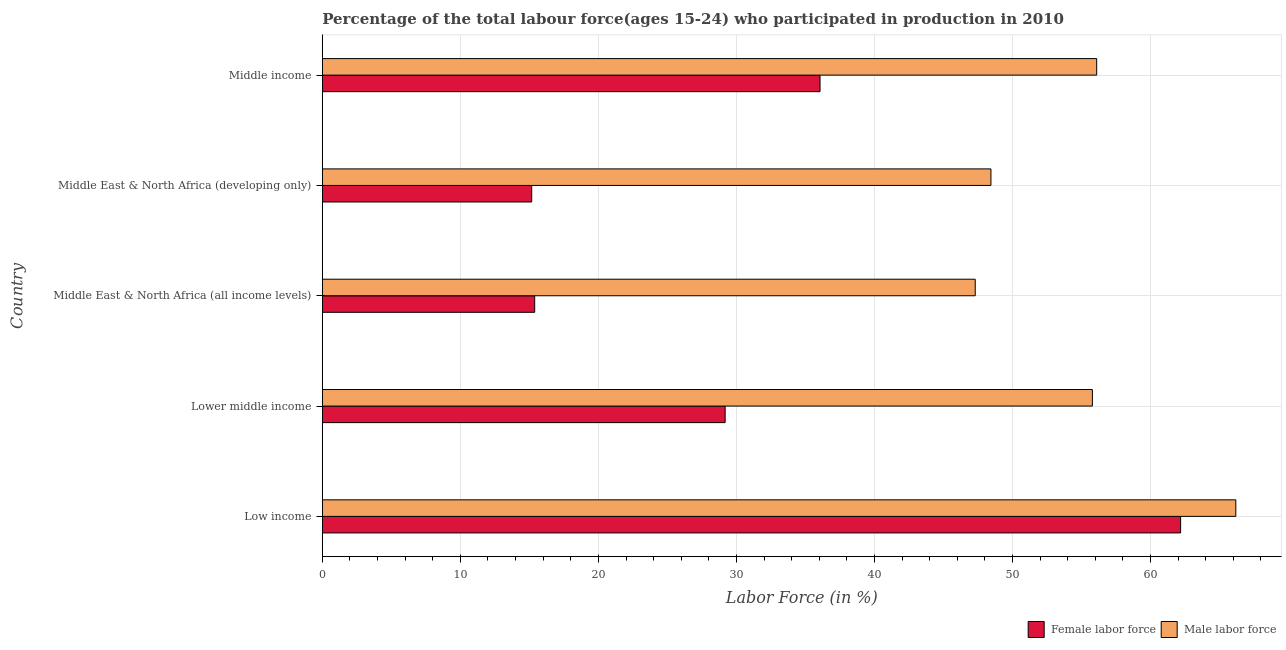How many groups of bars are there?
Offer a very short reply. 5. Are the number of bars per tick equal to the number of legend labels?
Keep it short and to the point. Yes. What is the label of the 1st group of bars from the top?
Your response must be concise. Middle income. In how many cases, is the number of bars for a given country not equal to the number of legend labels?
Keep it short and to the point. 0. What is the percentage of male labour force in Middle East & North Africa (developing only)?
Keep it short and to the point. 48.44. Across all countries, what is the maximum percentage of female labor force?
Your answer should be very brief. 62.18. Across all countries, what is the minimum percentage of male labour force?
Give a very brief answer. 47.3. In which country was the percentage of male labour force minimum?
Offer a very short reply. Middle East & North Africa (all income levels). What is the total percentage of female labor force in the graph?
Provide a short and direct response. 157.97. What is the difference between the percentage of female labor force in Low income and that in Middle East & North Africa (all income levels)?
Make the answer very short. 46.79. What is the difference between the percentage of male labour force in Middle income and the percentage of female labor force in Middle East & North Africa (developing only)?
Provide a short and direct response. 40.93. What is the average percentage of male labour force per country?
Your answer should be compact. 54.76. What is the difference between the percentage of female labor force and percentage of male labour force in Lower middle income?
Offer a very short reply. -26.61. In how many countries, is the percentage of female labor force greater than 64 %?
Give a very brief answer. 0. What is the ratio of the percentage of female labor force in Lower middle income to that in Middle East & North Africa (developing only)?
Offer a terse response. 1.92. Is the percentage of male labour force in Low income less than that in Lower middle income?
Provide a succinct answer. No. Is the difference between the percentage of male labour force in Middle East & North Africa (developing only) and Middle income greater than the difference between the percentage of female labor force in Middle East & North Africa (developing only) and Middle income?
Keep it short and to the point. Yes. What is the difference between the highest and the second highest percentage of female labor force?
Ensure brevity in your answer.  26.12. What is the difference between the highest and the lowest percentage of male labour force?
Your answer should be compact. 18.88. What does the 2nd bar from the top in Middle income represents?
Offer a very short reply. Female labor force. What does the 2nd bar from the bottom in Middle East & North Africa (all income levels) represents?
Offer a very short reply. Male labor force. What is the difference between two consecutive major ticks on the X-axis?
Provide a succinct answer. 10. Does the graph contain any zero values?
Your answer should be very brief. No. Where does the legend appear in the graph?
Offer a very short reply. Bottom right. What is the title of the graph?
Your answer should be very brief. Percentage of the total labour force(ages 15-24) who participated in production in 2010. Does "Urban Population" appear as one of the legend labels in the graph?
Your response must be concise. No. What is the label or title of the X-axis?
Make the answer very short. Labor Force (in %). What is the Labor Force (in %) of Female labor force in Low income?
Give a very brief answer. 62.18. What is the Labor Force (in %) in Male labor force in Low income?
Offer a terse response. 66.18. What is the Labor Force (in %) of Female labor force in Lower middle income?
Your answer should be compact. 29.18. What is the Labor Force (in %) of Male labor force in Lower middle income?
Provide a short and direct response. 55.79. What is the Labor Force (in %) in Female labor force in Middle East & North Africa (all income levels)?
Your response must be concise. 15.38. What is the Labor Force (in %) of Male labor force in Middle East & North Africa (all income levels)?
Your response must be concise. 47.3. What is the Labor Force (in %) in Female labor force in Middle East & North Africa (developing only)?
Keep it short and to the point. 15.17. What is the Labor Force (in %) in Male labor force in Middle East & North Africa (developing only)?
Offer a very short reply. 48.44. What is the Labor Force (in %) of Female labor force in Middle income?
Offer a terse response. 36.06. What is the Labor Force (in %) of Male labor force in Middle income?
Offer a terse response. 56.1. Across all countries, what is the maximum Labor Force (in %) in Female labor force?
Provide a short and direct response. 62.18. Across all countries, what is the maximum Labor Force (in %) of Male labor force?
Your answer should be very brief. 66.18. Across all countries, what is the minimum Labor Force (in %) in Female labor force?
Ensure brevity in your answer.  15.17. Across all countries, what is the minimum Labor Force (in %) in Male labor force?
Your answer should be compact. 47.3. What is the total Labor Force (in %) of Female labor force in the graph?
Offer a very short reply. 157.97. What is the total Labor Force (in %) in Male labor force in the graph?
Your answer should be very brief. 273.8. What is the difference between the Labor Force (in %) in Female labor force in Low income and that in Lower middle income?
Provide a short and direct response. 33. What is the difference between the Labor Force (in %) of Male labor force in Low income and that in Lower middle income?
Offer a very short reply. 10.39. What is the difference between the Labor Force (in %) in Female labor force in Low income and that in Middle East & North Africa (all income levels)?
Offer a terse response. 46.79. What is the difference between the Labor Force (in %) in Male labor force in Low income and that in Middle East & North Africa (all income levels)?
Your answer should be compact. 18.88. What is the difference between the Labor Force (in %) of Female labor force in Low income and that in Middle East & North Africa (developing only)?
Your response must be concise. 47.01. What is the difference between the Labor Force (in %) in Male labor force in Low income and that in Middle East & North Africa (developing only)?
Offer a terse response. 17.74. What is the difference between the Labor Force (in %) of Female labor force in Low income and that in Middle income?
Offer a very short reply. 26.12. What is the difference between the Labor Force (in %) of Male labor force in Low income and that in Middle income?
Offer a terse response. 10.08. What is the difference between the Labor Force (in %) of Female labor force in Lower middle income and that in Middle East & North Africa (all income levels)?
Give a very brief answer. 13.8. What is the difference between the Labor Force (in %) of Male labor force in Lower middle income and that in Middle East & North Africa (all income levels)?
Ensure brevity in your answer.  8.49. What is the difference between the Labor Force (in %) in Female labor force in Lower middle income and that in Middle East & North Africa (developing only)?
Ensure brevity in your answer.  14.01. What is the difference between the Labor Force (in %) in Male labor force in Lower middle income and that in Middle East & North Africa (developing only)?
Keep it short and to the point. 7.35. What is the difference between the Labor Force (in %) in Female labor force in Lower middle income and that in Middle income?
Provide a succinct answer. -6.87. What is the difference between the Labor Force (in %) of Male labor force in Lower middle income and that in Middle income?
Offer a very short reply. -0.31. What is the difference between the Labor Force (in %) in Female labor force in Middle East & North Africa (all income levels) and that in Middle East & North Africa (developing only)?
Keep it short and to the point. 0.22. What is the difference between the Labor Force (in %) in Male labor force in Middle East & North Africa (all income levels) and that in Middle East & North Africa (developing only)?
Provide a short and direct response. -1.14. What is the difference between the Labor Force (in %) in Female labor force in Middle East & North Africa (all income levels) and that in Middle income?
Make the answer very short. -20.67. What is the difference between the Labor Force (in %) in Male labor force in Middle East & North Africa (all income levels) and that in Middle income?
Keep it short and to the point. -8.8. What is the difference between the Labor Force (in %) in Female labor force in Middle East & North Africa (developing only) and that in Middle income?
Your response must be concise. -20.89. What is the difference between the Labor Force (in %) of Male labor force in Middle East & North Africa (developing only) and that in Middle income?
Your answer should be very brief. -7.66. What is the difference between the Labor Force (in %) in Female labor force in Low income and the Labor Force (in %) in Male labor force in Lower middle income?
Provide a short and direct response. 6.39. What is the difference between the Labor Force (in %) in Female labor force in Low income and the Labor Force (in %) in Male labor force in Middle East & North Africa (all income levels)?
Provide a succinct answer. 14.88. What is the difference between the Labor Force (in %) in Female labor force in Low income and the Labor Force (in %) in Male labor force in Middle East & North Africa (developing only)?
Provide a short and direct response. 13.74. What is the difference between the Labor Force (in %) of Female labor force in Low income and the Labor Force (in %) of Male labor force in Middle income?
Offer a terse response. 6.08. What is the difference between the Labor Force (in %) in Female labor force in Lower middle income and the Labor Force (in %) in Male labor force in Middle East & North Africa (all income levels)?
Give a very brief answer. -18.12. What is the difference between the Labor Force (in %) in Female labor force in Lower middle income and the Labor Force (in %) in Male labor force in Middle East & North Africa (developing only)?
Give a very brief answer. -19.26. What is the difference between the Labor Force (in %) of Female labor force in Lower middle income and the Labor Force (in %) of Male labor force in Middle income?
Provide a succinct answer. -26.92. What is the difference between the Labor Force (in %) in Female labor force in Middle East & North Africa (all income levels) and the Labor Force (in %) in Male labor force in Middle East & North Africa (developing only)?
Your response must be concise. -33.05. What is the difference between the Labor Force (in %) in Female labor force in Middle East & North Africa (all income levels) and the Labor Force (in %) in Male labor force in Middle income?
Offer a very short reply. -40.71. What is the difference between the Labor Force (in %) of Female labor force in Middle East & North Africa (developing only) and the Labor Force (in %) of Male labor force in Middle income?
Give a very brief answer. -40.93. What is the average Labor Force (in %) of Female labor force per country?
Provide a short and direct response. 31.59. What is the average Labor Force (in %) in Male labor force per country?
Make the answer very short. 54.76. What is the difference between the Labor Force (in %) in Female labor force and Labor Force (in %) in Male labor force in Low income?
Your answer should be very brief. -4. What is the difference between the Labor Force (in %) of Female labor force and Labor Force (in %) of Male labor force in Lower middle income?
Give a very brief answer. -26.61. What is the difference between the Labor Force (in %) in Female labor force and Labor Force (in %) in Male labor force in Middle East & North Africa (all income levels)?
Offer a terse response. -31.91. What is the difference between the Labor Force (in %) of Female labor force and Labor Force (in %) of Male labor force in Middle East & North Africa (developing only)?
Your response must be concise. -33.27. What is the difference between the Labor Force (in %) of Female labor force and Labor Force (in %) of Male labor force in Middle income?
Keep it short and to the point. -20.04. What is the ratio of the Labor Force (in %) in Female labor force in Low income to that in Lower middle income?
Your response must be concise. 2.13. What is the ratio of the Labor Force (in %) in Male labor force in Low income to that in Lower middle income?
Your answer should be compact. 1.19. What is the ratio of the Labor Force (in %) in Female labor force in Low income to that in Middle East & North Africa (all income levels)?
Make the answer very short. 4.04. What is the ratio of the Labor Force (in %) in Male labor force in Low income to that in Middle East & North Africa (all income levels)?
Keep it short and to the point. 1.4. What is the ratio of the Labor Force (in %) of Female labor force in Low income to that in Middle East & North Africa (developing only)?
Your response must be concise. 4.1. What is the ratio of the Labor Force (in %) in Male labor force in Low income to that in Middle East & North Africa (developing only)?
Keep it short and to the point. 1.37. What is the ratio of the Labor Force (in %) in Female labor force in Low income to that in Middle income?
Your answer should be compact. 1.72. What is the ratio of the Labor Force (in %) in Male labor force in Low income to that in Middle income?
Your answer should be very brief. 1.18. What is the ratio of the Labor Force (in %) of Female labor force in Lower middle income to that in Middle East & North Africa (all income levels)?
Ensure brevity in your answer.  1.9. What is the ratio of the Labor Force (in %) in Male labor force in Lower middle income to that in Middle East & North Africa (all income levels)?
Provide a succinct answer. 1.18. What is the ratio of the Labor Force (in %) in Female labor force in Lower middle income to that in Middle East & North Africa (developing only)?
Keep it short and to the point. 1.92. What is the ratio of the Labor Force (in %) in Male labor force in Lower middle income to that in Middle East & North Africa (developing only)?
Ensure brevity in your answer.  1.15. What is the ratio of the Labor Force (in %) in Female labor force in Lower middle income to that in Middle income?
Ensure brevity in your answer.  0.81. What is the ratio of the Labor Force (in %) in Male labor force in Lower middle income to that in Middle income?
Make the answer very short. 0.99. What is the ratio of the Labor Force (in %) in Female labor force in Middle East & North Africa (all income levels) to that in Middle East & North Africa (developing only)?
Offer a very short reply. 1.01. What is the ratio of the Labor Force (in %) of Male labor force in Middle East & North Africa (all income levels) to that in Middle East & North Africa (developing only)?
Your response must be concise. 0.98. What is the ratio of the Labor Force (in %) of Female labor force in Middle East & North Africa (all income levels) to that in Middle income?
Make the answer very short. 0.43. What is the ratio of the Labor Force (in %) of Male labor force in Middle East & North Africa (all income levels) to that in Middle income?
Your answer should be very brief. 0.84. What is the ratio of the Labor Force (in %) of Female labor force in Middle East & North Africa (developing only) to that in Middle income?
Make the answer very short. 0.42. What is the ratio of the Labor Force (in %) of Male labor force in Middle East & North Africa (developing only) to that in Middle income?
Provide a succinct answer. 0.86. What is the difference between the highest and the second highest Labor Force (in %) in Female labor force?
Offer a terse response. 26.12. What is the difference between the highest and the second highest Labor Force (in %) of Male labor force?
Give a very brief answer. 10.08. What is the difference between the highest and the lowest Labor Force (in %) of Female labor force?
Your answer should be compact. 47.01. What is the difference between the highest and the lowest Labor Force (in %) of Male labor force?
Your answer should be compact. 18.88. 